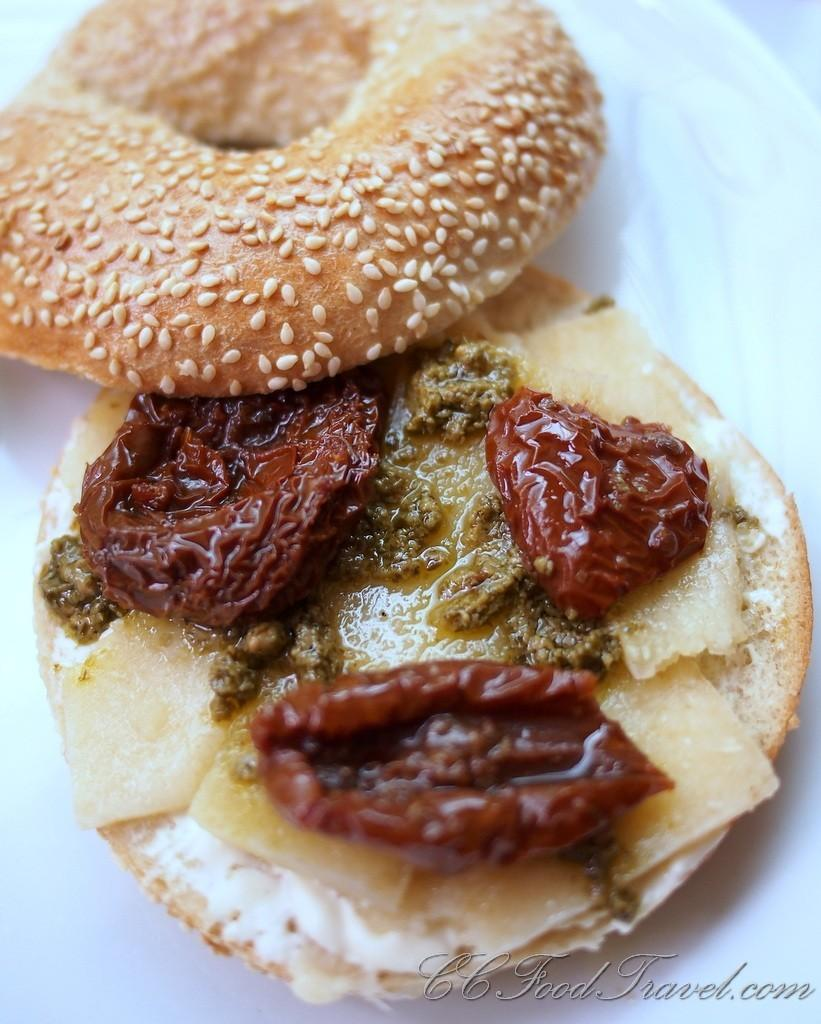What type of food can be seen in the image? The image contains eatables that resemble a burger. Can you describe the specific type of eatable in the image? The eatables in the image resemble a burger. How many pizzas can be seen floating in the sky in the image? There are no pizzas visible in the image, nor are there any pizzas floating in the sky. What type of coat is the cloud wearing in the image? There is no cloud or coat present in the image. 